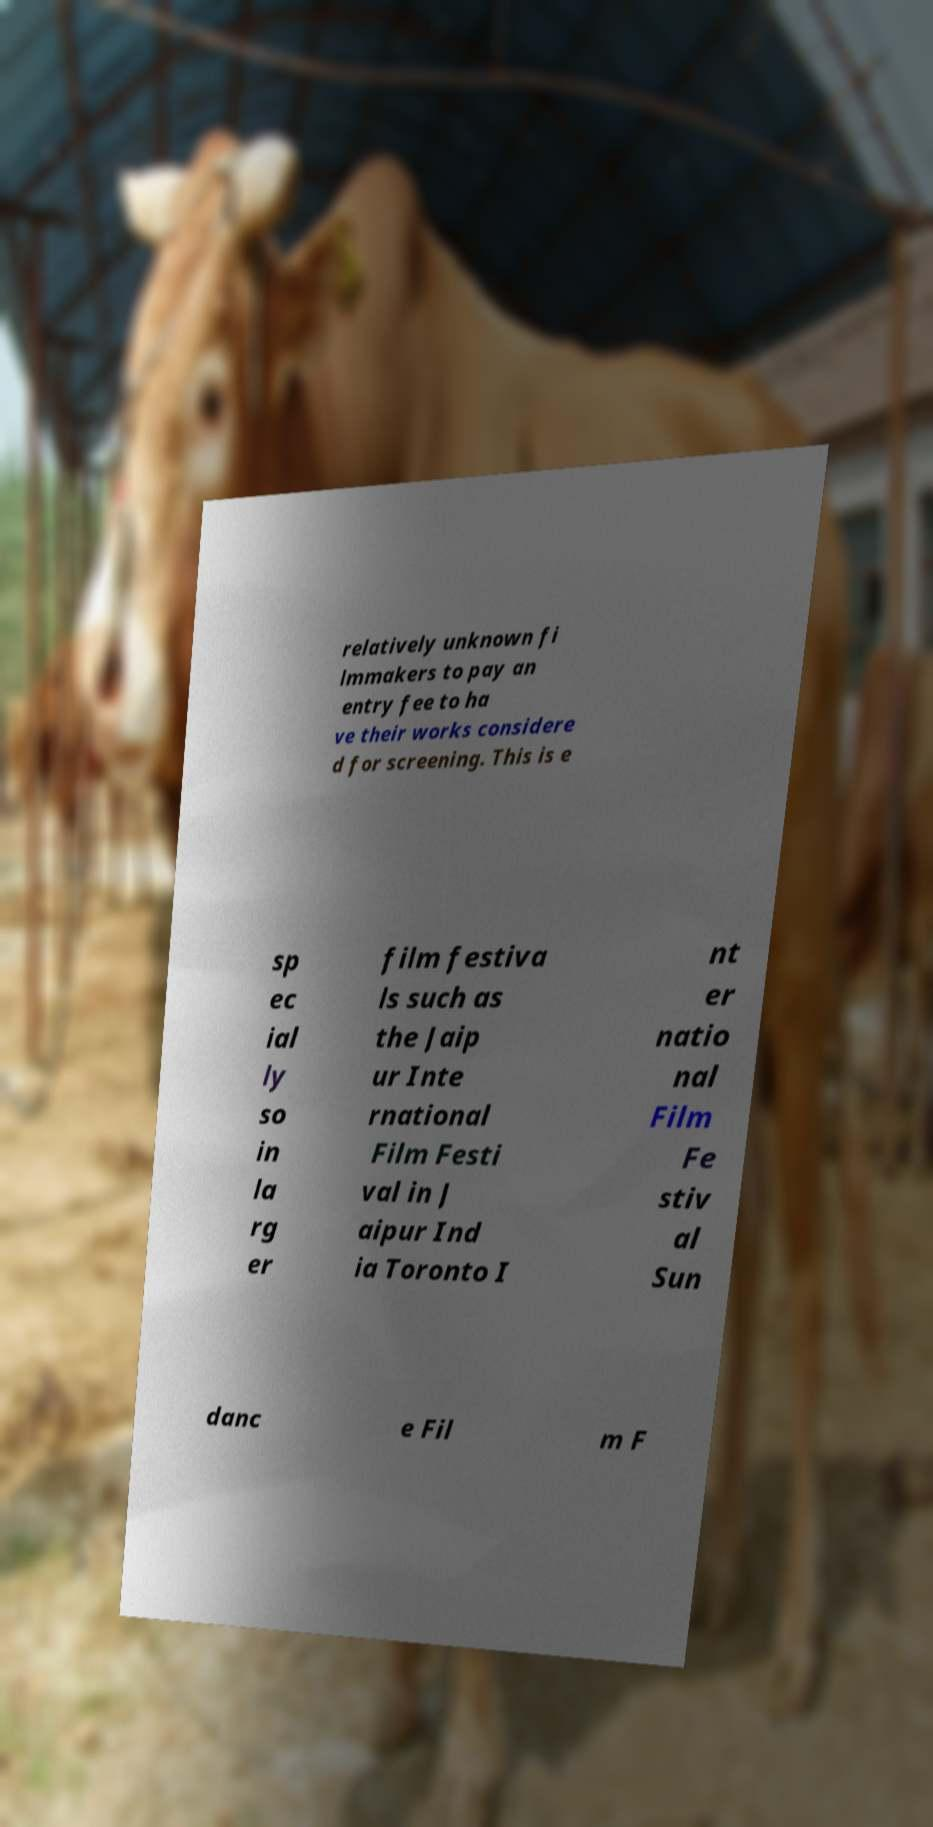I need the written content from this picture converted into text. Can you do that? relatively unknown fi lmmakers to pay an entry fee to ha ve their works considere d for screening. This is e sp ec ial ly so in la rg er film festiva ls such as the Jaip ur Inte rnational Film Festi val in J aipur Ind ia Toronto I nt er natio nal Film Fe stiv al Sun danc e Fil m F 